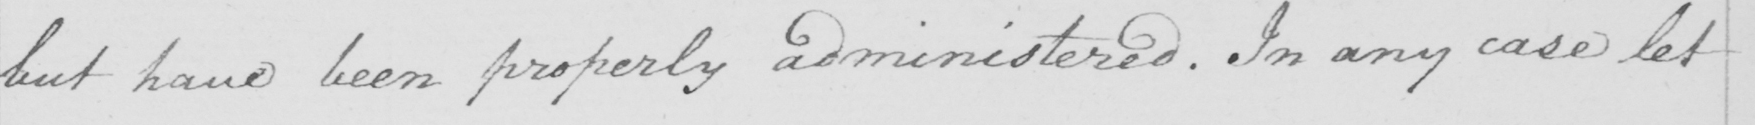Please provide the text content of this handwritten line. but have been properly administered. In any case let 